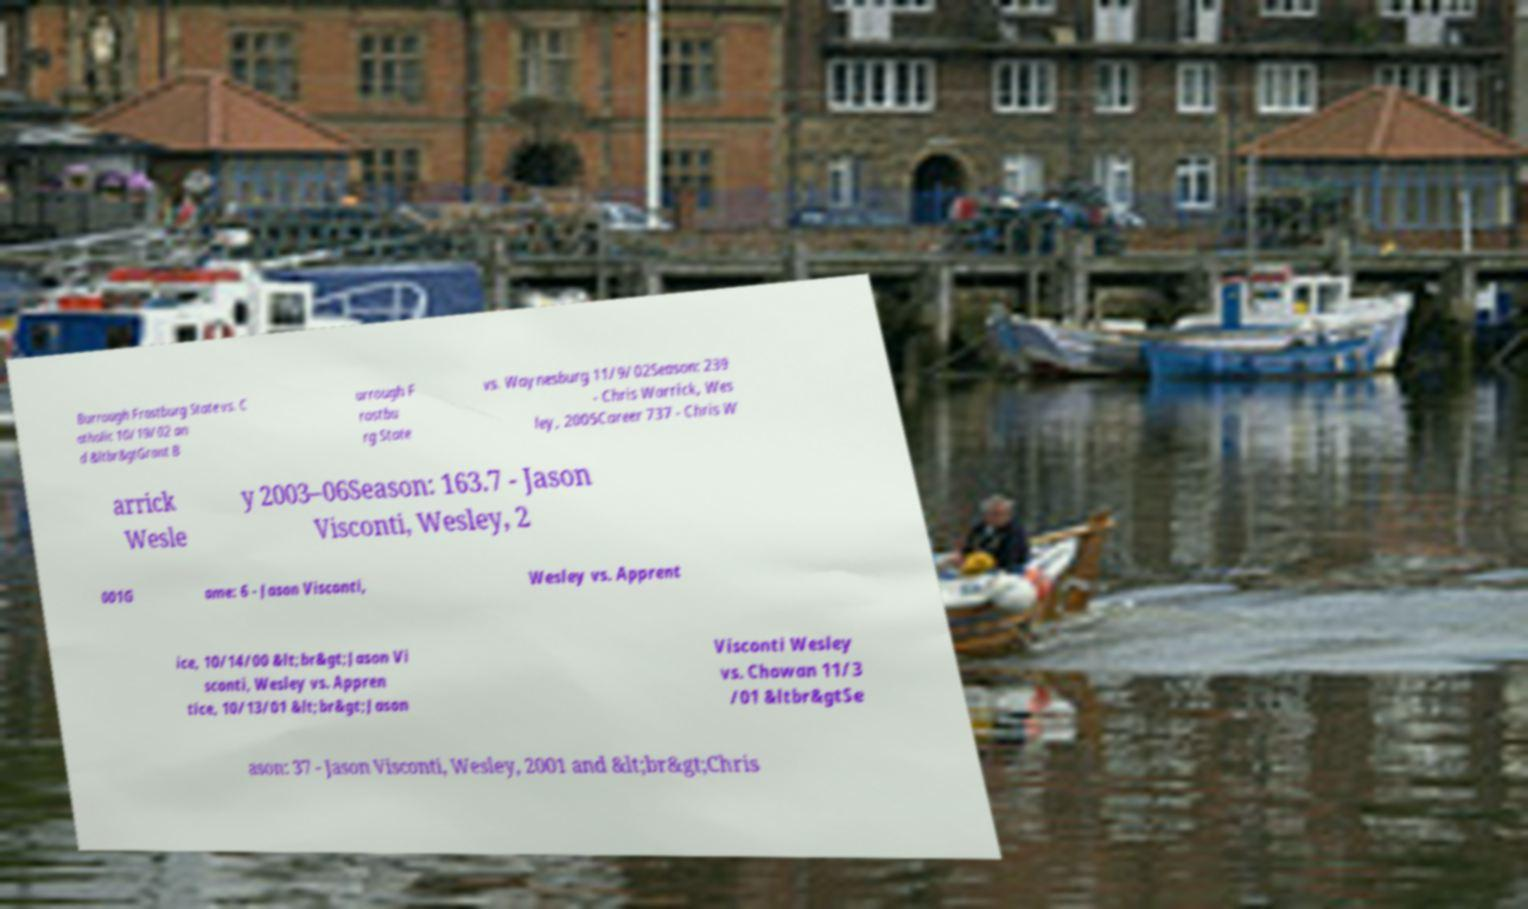What messages or text are displayed in this image? I need them in a readable, typed format. Burrough Frostburg State vs. C atholic 10/19/02 an d &ltbr&gtGrant B urrough F rostbu rg State vs. Waynesburg 11/9/02Season: 239 - Chris Warrick, Wes ley, 2005Career 737 - Chris W arrick Wesle y 2003–06Season: 163.7 - Jason Visconti, Wesley, 2 001G ame: 6 - Jason Visconti, Wesley vs. Apprent ice, 10/14/00 &lt;br&gt;Jason Vi sconti, Wesley vs. Appren tice, 10/13/01 &lt;br&gt;Jason Visconti Wesley vs. Chowan 11/3 /01 &ltbr&gtSe ason: 37 - Jason Visconti, Wesley, 2001 and &lt;br&gt;Chris 